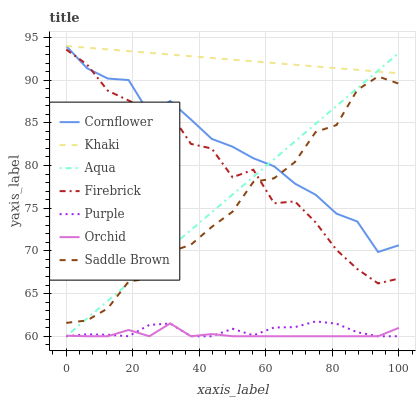Does Purple have the minimum area under the curve?
Answer yes or no. No. Does Purple have the maximum area under the curve?
Answer yes or no. No. Is Purple the smoothest?
Answer yes or no. No. Is Purple the roughest?
Answer yes or no. No. Does Khaki have the lowest value?
Answer yes or no. No. Does Purple have the highest value?
Answer yes or no. No. Is Saddle Brown less than Khaki?
Answer yes or no. Yes. Is Firebrick greater than Purple?
Answer yes or no. Yes. Does Saddle Brown intersect Khaki?
Answer yes or no. No. 